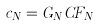Convert formula to latex. <formula><loc_0><loc_0><loc_500><loc_500>c _ { N } = G _ { N } C F _ { N }</formula> 